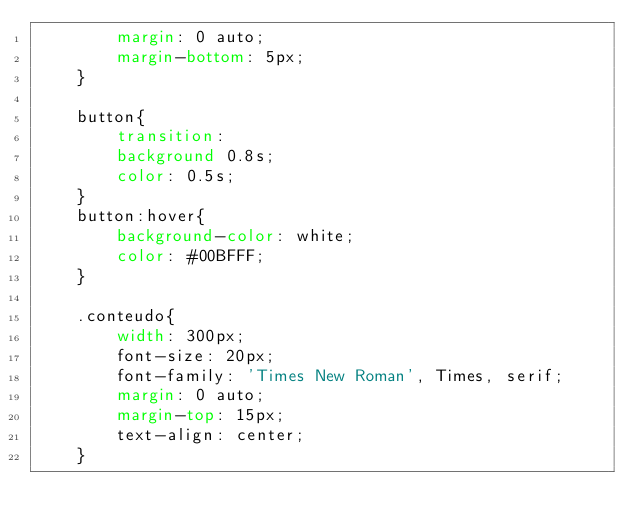Convert code to text. <code><loc_0><loc_0><loc_500><loc_500><_CSS_>        margin: 0 auto;
        margin-bottom: 5px;
    }

    button{
        transition:
        background 0.8s;
        color: 0.5s;
    }
    button:hover{
        background-color: white;
        color: #00BFFF;
    }

    .conteudo{
        width: 300px;
        font-size: 20px;
        font-family: 'Times New Roman', Times, serif;
        margin: 0 auto;
        margin-top: 15px;
        text-align: center;
    }
</code> 